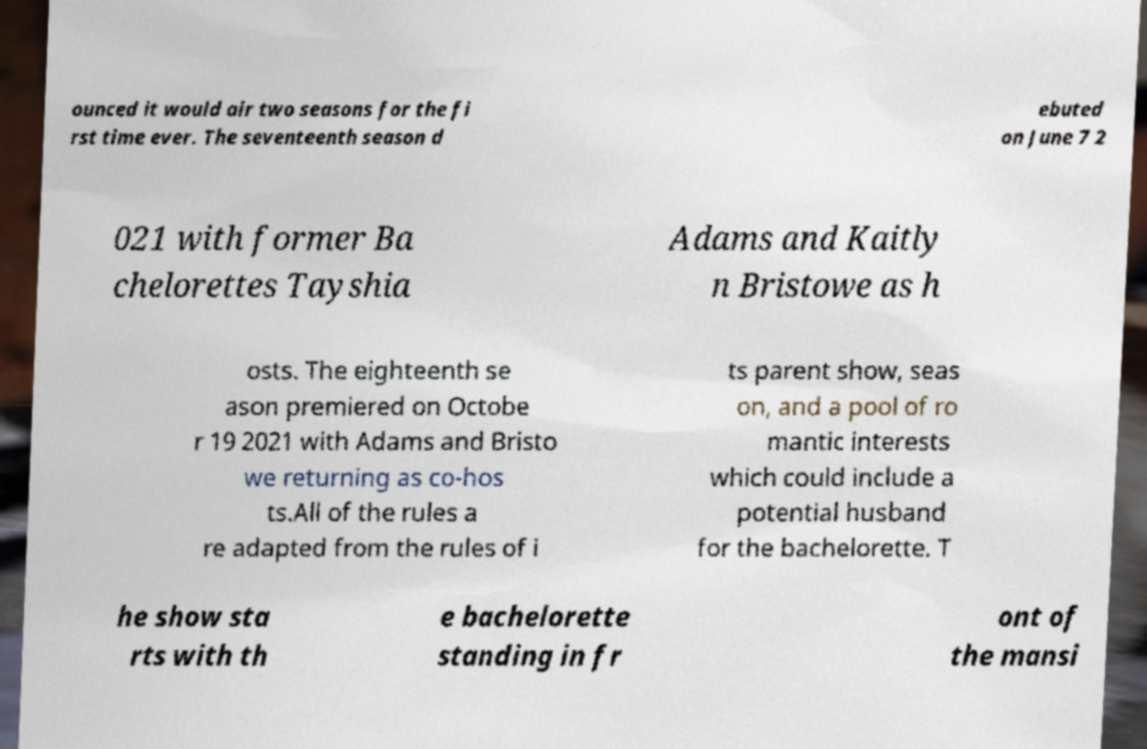Can you accurately transcribe the text from the provided image for me? ounced it would air two seasons for the fi rst time ever. The seventeenth season d ebuted on June 7 2 021 with former Ba chelorettes Tayshia Adams and Kaitly n Bristowe as h osts. The eighteenth se ason premiered on Octobe r 19 2021 with Adams and Bristo we returning as co-hos ts.All of the rules a re adapted from the rules of i ts parent show, seas on, and a pool of ro mantic interests which could include a potential husband for the bachelorette. T he show sta rts with th e bachelorette standing in fr ont of the mansi 